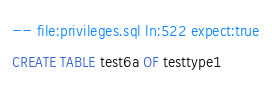Convert code to text. <code><loc_0><loc_0><loc_500><loc_500><_SQL_>-- file:privileges.sql ln:522 expect:true
CREATE TABLE test6a OF testtype1
</code> 